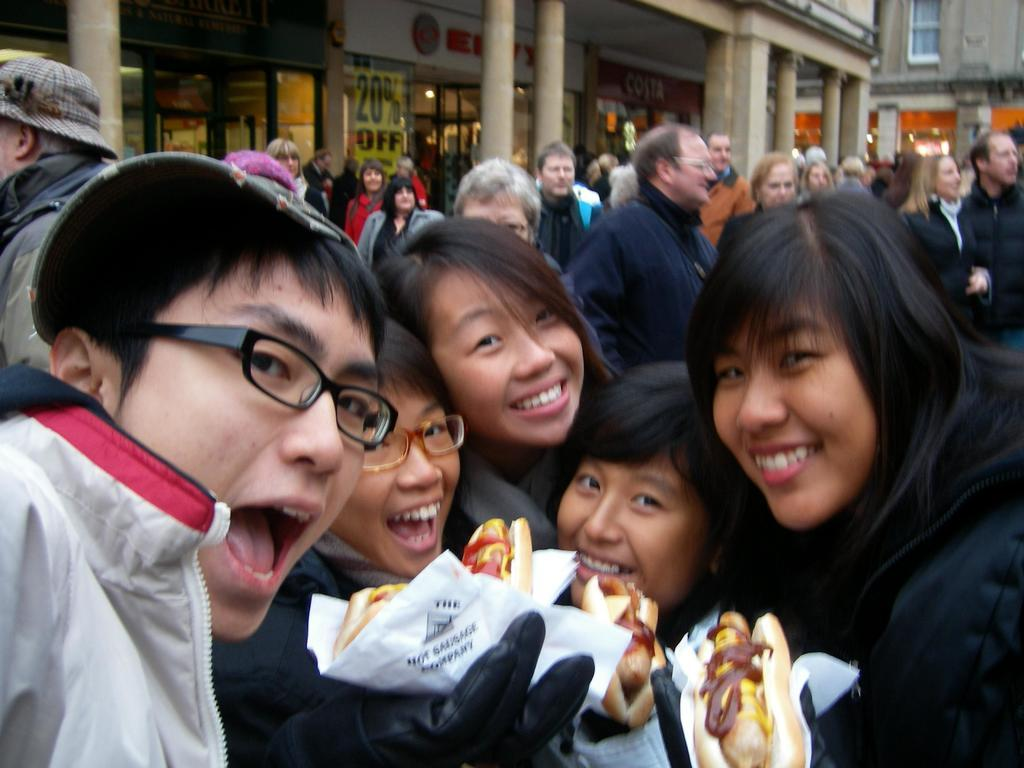How many people are in the image? There is a group of people in the image, but the exact number cannot be determined from the provided facts. What are some of the people in the image doing? Some persons are holding food items in the image. What can be seen in the background of the image? There are buildings and pillars in the background of the image. What type of orange tree can be seen in the alley behind the people in the image? There is no orange tree or alley present in the image; it features a group of people and buildings in the background. 